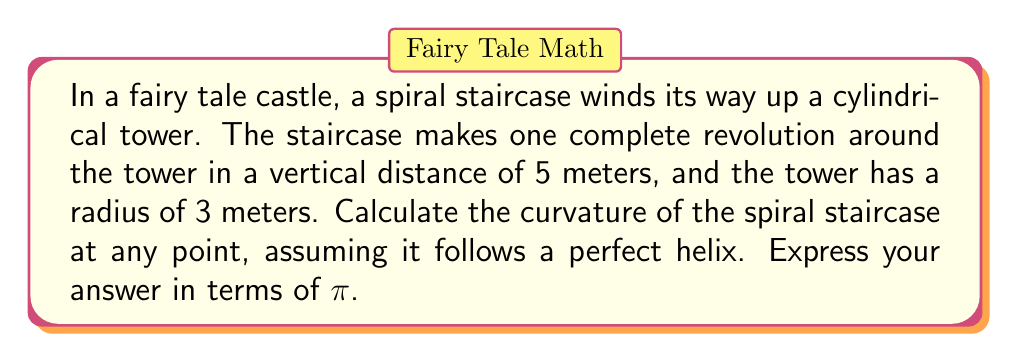Could you help me with this problem? To calculate the curvature of the spiral staircase, we'll follow these steps:

1) First, we need to parameterize the helix. Let's use the following parametric equations:

   $$x = r\cos(t)$$
   $$y = r\sin(t)$$
   $$z = ht$$

   Where $r$ is the radius of the cylinder, $h$ is the height gained in one revolution, and $t$ is the parameter.

2) In our case, $r = 3$ and $h = 5$. So our parametric equations are:

   $$x = 3\cos(t)$$
   $$y = 3\sin(t)$$
   $$z = 5t$$

3) To calculate curvature, we need the first and second derivatives of these equations:

   $$x' = -3\sin(t), \quad x'' = -3\cos(t)$$
   $$y' = 3\cos(t), \quad y'' = -3\sin(t)$$
   $$z' = 5, \quad z'' = 0$$

4) The curvature formula for a space curve is:

   $$\kappa = \frac{\sqrt{|\mathbf{r'} \times \mathbf{r''}|^2}}{|\mathbf{r'}|^3}$$

   Where $\mathbf{r'} = (x', y', z')$ and $\mathbf{r''} = (x'', y'', z'')$

5) Let's calculate $\mathbf{r'} \times \mathbf{r''}$:

   $$\mathbf{r'} \times \mathbf{r''} = \begin{vmatrix} 
   \mathbf{i} & \mathbf{j} & \mathbf{k} \\
   -3\sin(t) & 3\cos(t) & 5 \\
   -3\cos(t) & -3\sin(t) & 0
   \end{vmatrix}$$

   $$= (15\sin(t))\mathbf{i} + (15\cos(t))\mathbf{j} + (9)\mathbf{k}$$

6) The magnitude of this cross product is:

   $$|\mathbf{r'} \times \mathbf{r''}| = \sqrt{(15\sin(t))^2 + (15\cos(t))^2 + 9^2} = \sqrt{225 + 81} = \sqrt{306}$$

7) Now, let's calculate $|\mathbf{r'}|$:

   $$|\mathbf{r'}| = \sqrt{(-3\sin(t))^2 + (3\cos(t))^2 + 5^2} = \sqrt{9 + 25} = \sqrt{34}$$

8) Putting this into our curvature formula:

   $$\kappa = \frac{\sqrt{306}}{(\sqrt{34})^3} = \frac{\sqrt{306}}{34\sqrt{34}}$$

9) To simplify this, let's rationalize the denominator:

   $$\kappa = \frac{\sqrt{306}}{34\sqrt{34}} \cdot \frac{\sqrt{34}}{\sqrt{34}} = \frac{\sqrt{10404}}{1156} = \frac{102}{1156} = \frac{51}{578}$$

This is the curvature at any point on the spiral staircase.
Answer: $\frac{51}{578}$ 